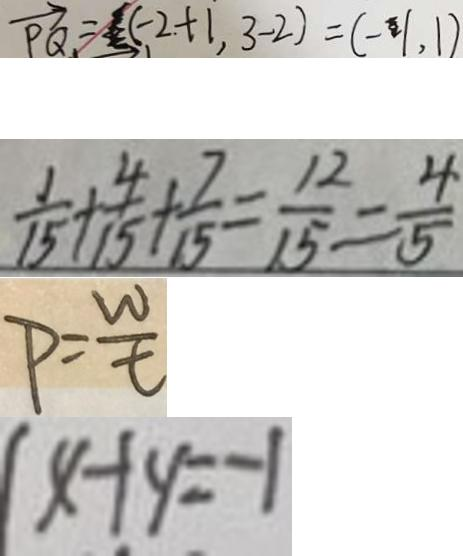Convert formula to latex. <formula><loc_0><loc_0><loc_500><loc_500>\overrightarrow { P Q } = ( - 2 + 1 , 3 - 2 ) = ( - 1 , 1 ) 
 \frac { 1 } { 1 5 } + \frac { 4 } { 1 5 } + \frac { 7 } { 1 5 } = \frac { 1 2 } { 1 5 } = \frac { 4 } { 5 } 
 P = \frac { w } { t } 
 x + y = - 1</formula> 